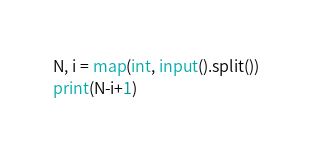<code> <loc_0><loc_0><loc_500><loc_500><_Python_>N, i = map(int, input().split())
print(N-i+1)</code> 